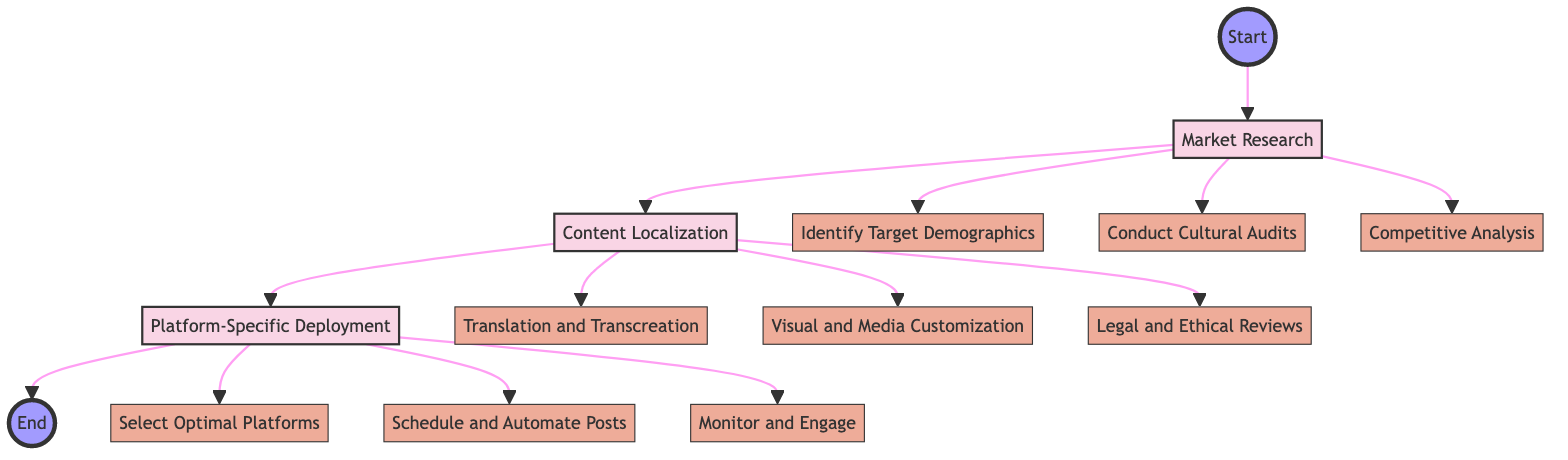What is the first stage in the process? The first stage indicated in the flowchart is "Market Research", which is represented as the initial node after "Start".
Answer: Market Research How many steps are involved in the "Content Localization" stage? The "Content Localization" stage connects to three steps, including "Translation and Transcreation," "Visual and Media Customization," and "Legal and Ethical Reviews."
Answer: 3 What step follows "Competitive Analysis" in the flowchart? Following "Competitive Analysis," the next stage in the flowchart is "Content Localization," which connects directly after the Market Research steps.
Answer: Content Localization What is the last stage in the process? The last stage indicated in the flowchart is "Platform-Specific Deployment", which is the last node before reaching "End".
Answer: Platform-Specific Deployment Which tools are associated with "Monitor and Engage"? The tools associated with "Monitor and Engage" are identified in the diagram as "Brandwatch" and "Google Alerts," which are connected directly to this step.
Answer: Brandwatch, Google Alerts What stage includes "Conduct Cultural Audits"? The stage that includes the step "Conduct Cultural Audits" is "Market Research." In the diagram, it is shown as a connected step under Market Research.
Answer: Market Research What is the relationship between "Translation and Transcreation" and "Platform-Specific Deployment"? "Translation and Transcreation" is part of the "Content Localization" stage, while "Platform-Specific Deployment" is a subsequent stage that comes after Content Localization. There is no direct relationship between the two besides their sequence in the process.
Answer: Sequential How do you know that "Legal and Ethical Reviews" is part of the "Content Localization" stage? The flowchart has a direct connection from "Content Localization" to "Legal and Ethical Reviews," making it evident that this step is included within that stage.
Answer: Direct connection Which tools are proposed for "Select Optimal Platforms"? The tools suggested for "Select Optimal Platforms" are identified as "Sprout Social" and "Hootsuite" within the diagram.
Answer: Sprout Social, Hootsuite 